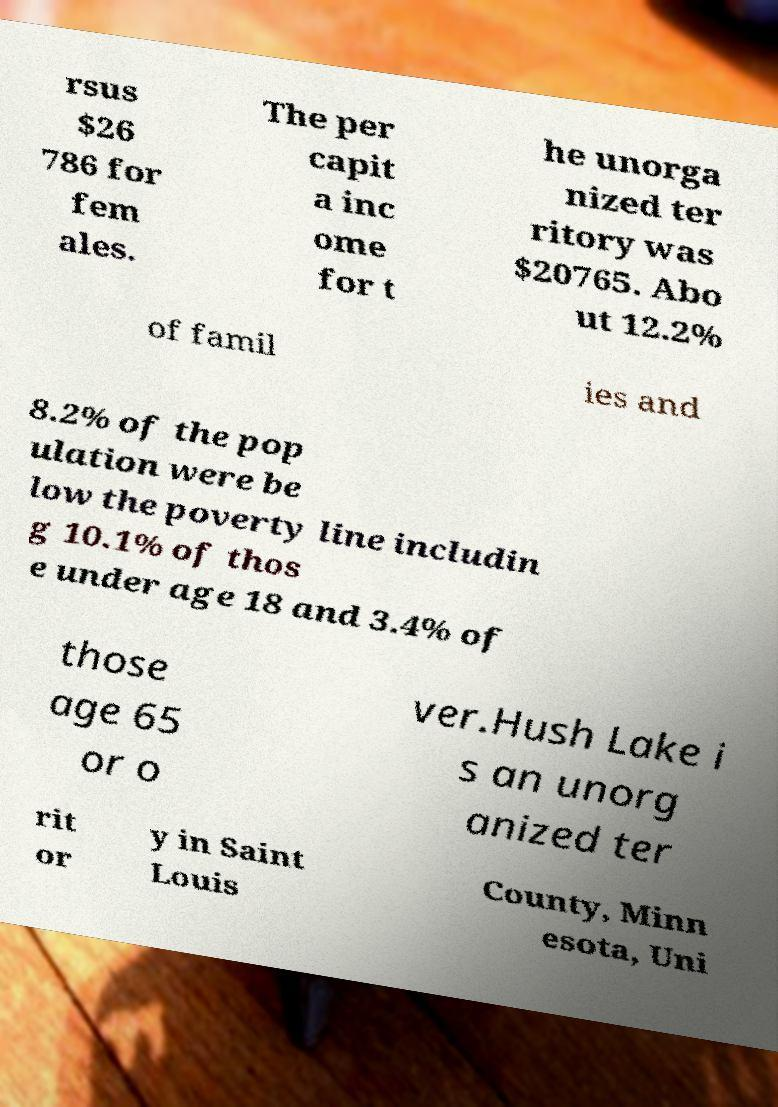Could you assist in decoding the text presented in this image and type it out clearly? rsus $26 786 for fem ales. The per capit a inc ome for t he unorga nized ter ritory was $20765. Abo ut 12.2% of famil ies and 8.2% of the pop ulation were be low the poverty line includin g 10.1% of thos e under age 18 and 3.4% of those age 65 or o ver.Hush Lake i s an unorg anized ter rit or y in Saint Louis County, Minn esota, Uni 